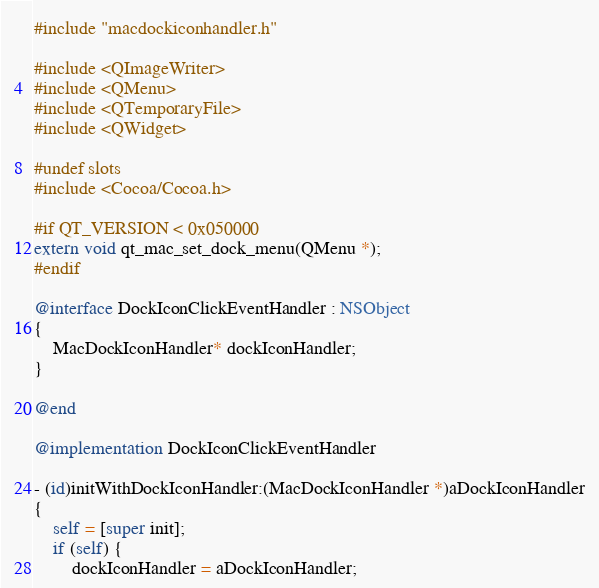<code> <loc_0><loc_0><loc_500><loc_500><_ObjectiveC_>#include "macdockiconhandler.h"

#include <QImageWriter>
#include <QMenu>
#include <QTemporaryFile>
#include <QWidget>

#undef slots
#include <Cocoa/Cocoa.h>

#if QT_VERSION < 0x050000
extern void qt_mac_set_dock_menu(QMenu *);
#endif

@interface DockIconClickEventHandler : NSObject
{
    MacDockIconHandler* dockIconHandler;
}

@end

@implementation DockIconClickEventHandler

- (id)initWithDockIconHandler:(MacDockIconHandler *)aDockIconHandler
{
    self = [super init];
    if (self) {
        dockIconHandler = aDockIconHandler;
</code> 